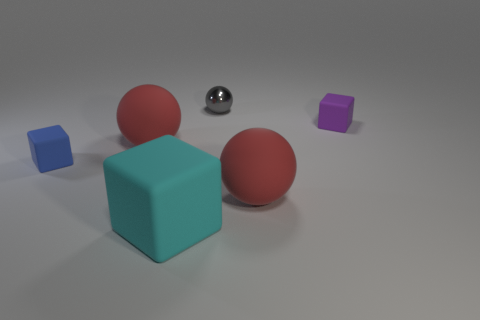There is a big sphere that is to the left of the large cyan rubber object; is its color the same as the large sphere that is in front of the small blue cube?
Provide a short and direct response. Yes. Is the material of the large red thing behind the blue rubber cube the same as the object behind the purple matte cube?
Provide a short and direct response. No. What number of red rubber cubes have the same size as the blue matte block?
Your response must be concise. 0. Is the number of gray metal spheres less than the number of red spheres?
Your answer should be very brief. Yes. There is a purple thing right of the sphere to the right of the small gray shiny thing; what shape is it?
Offer a terse response. Cube. What is the shape of the blue thing that is the same size as the purple rubber thing?
Your response must be concise. Cube. Are there any other cyan rubber objects of the same shape as the big cyan object?
Your answer should be compact. No. What is the material of the tiny gray object?
Your answer should be compact. Metal. Are there any large red rubber spheres behind the blue thing?
Give a very brief answer. Yes. There is a red sphere left of the gray thing; what number of large red balls are on the left side of it?
Keep it short and to the point. 0. 